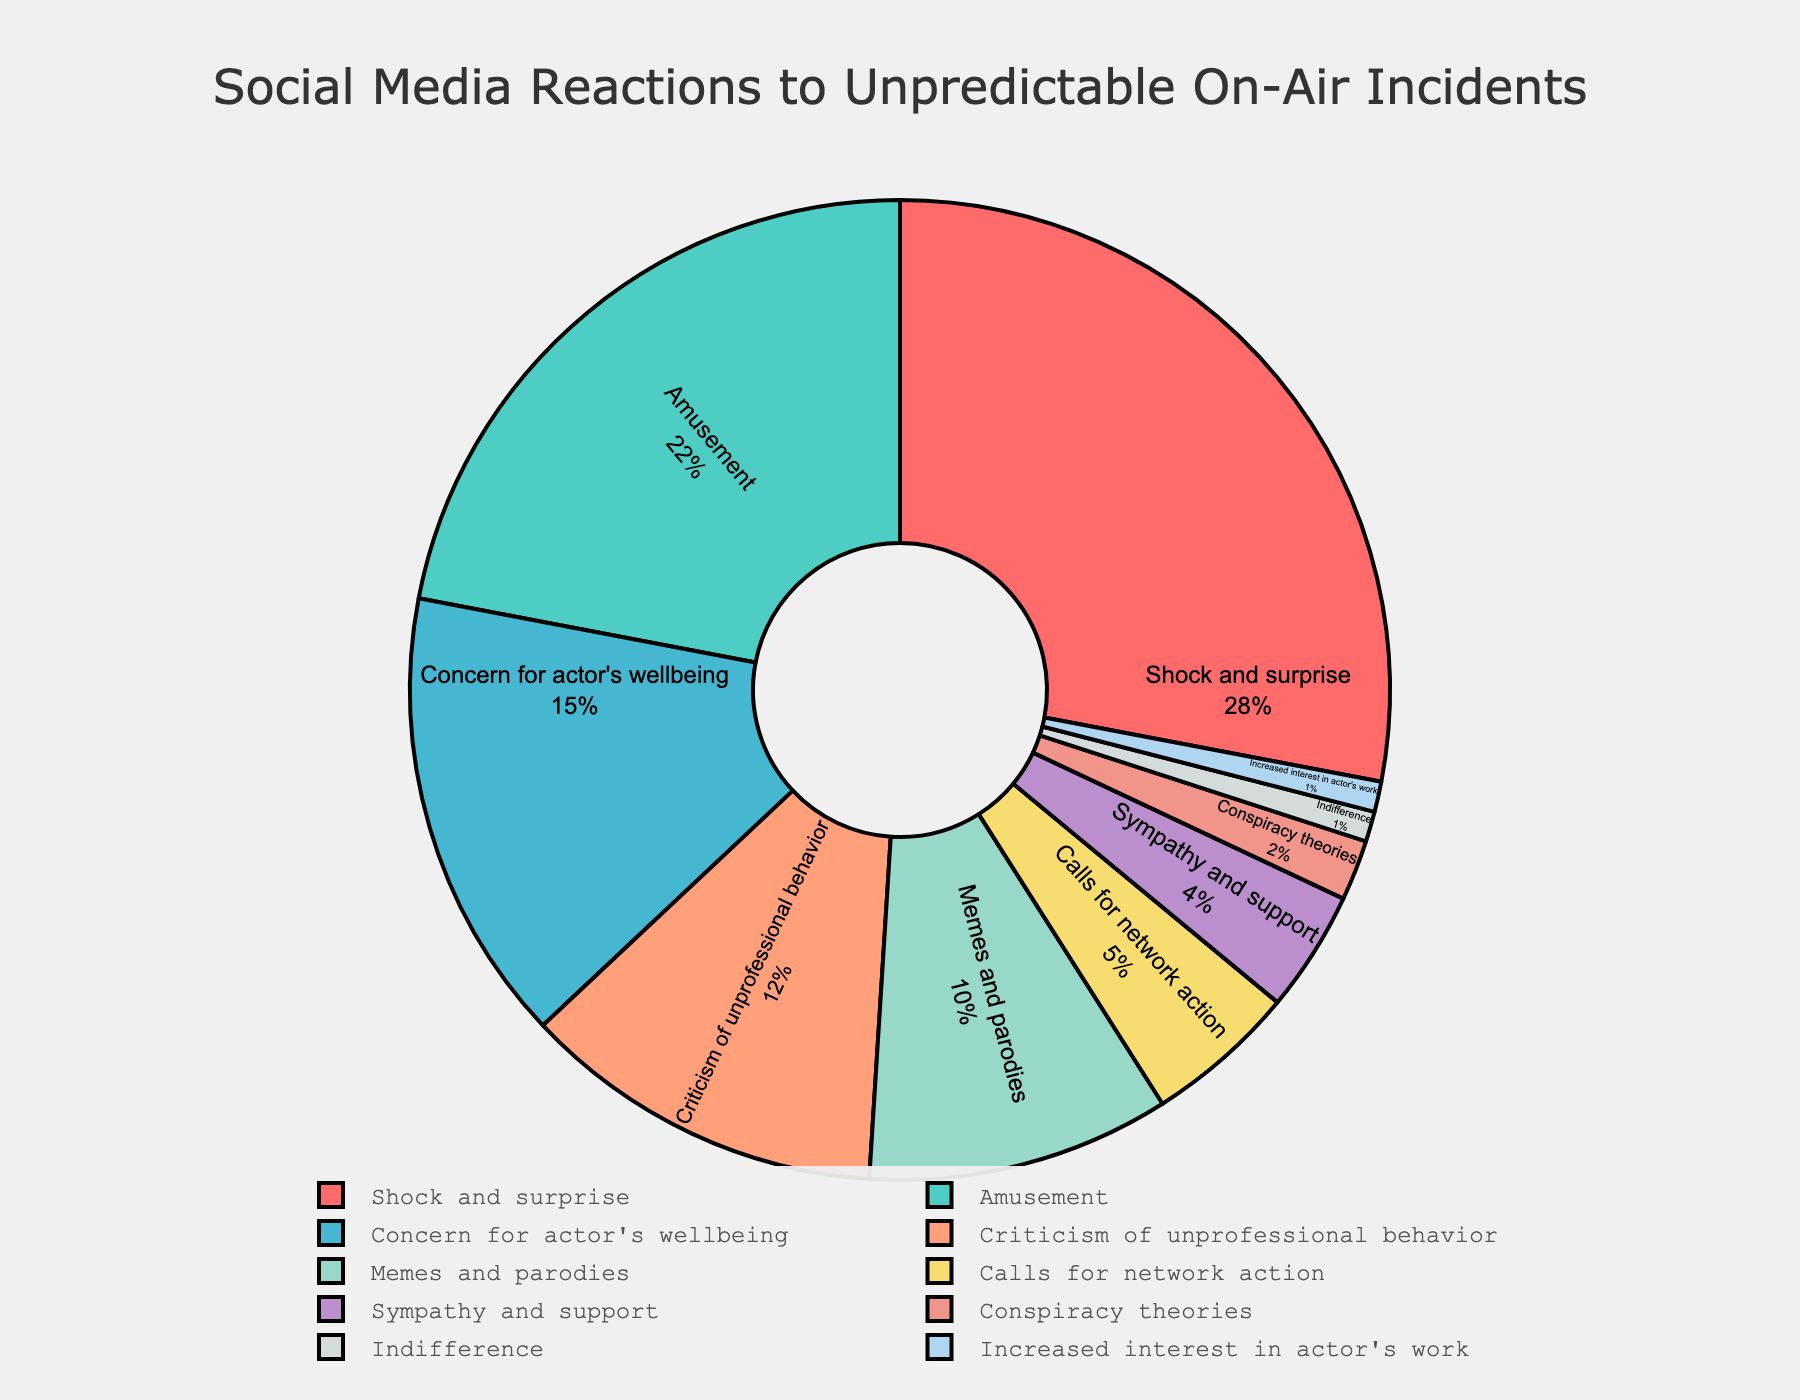What are the two highest percentage reactions to unpredictable on-air incidents? The pie chart shows the breakdown with each segment labeled with its respective percentage. The highest is "Shock and surprise" at 28%, followed by "Amusement" at 22%.
Answer: Shock and surprise, Amusement Which reaction has a higher percentage: Criticism of unprofessional behavior or Sympathy and support? Comparing the percentages in the pie chart, "Criticism of unprofessional behavior" is 12%, whereas "Sympathy and support" is 4%. Therefore, "Criticism of unprofessional behavior" is higher.
Answer: Criticism of unprofessional behavior What is the combined percentage of concern for actor's wellbeing and memes and parodies? The percentage for "Concern for actor's wellbeing" is 15% and for "Memes and parodies" is 10%. Adding these together gives 15% + 10% = 25%.
Answer: 25% Which reaction is indicated by the green segment in the pie chart? Observing the colors of the segments, the green segment corresponds to "Amusement".
Answer: Amusement By how much does the percentage of indifference differ from the percentage of increased interest in actor's work? The percentage for "Indifference" is 1% and for "Increased interest in actor's work" is also 1%. Therefore, the difference is 1% - 1% = 0%.
Answer: 0% Is the percentage of Calls for network action greater than the combined percentage of Conspiracy theories and Indifference? "Calls for network action" has a percentage of 5%. "Conspiracy theories" and "Indifference" have 2% and 1% respectively. Combined, they are 2% + 1% = 3%. Hence, 5% is greater than 3%.
Answer: Yes What is the total percentage of reactions categorized under Shock and surprise, Amusement, and Concern for actor's wellbeing? The percentages for "Shock and surprise", "Amusement", and "Concern for actor's wellbeing" are 28%, 22%, and 15% respectively. Adding these together gives 28% + 22% + 15% = 65%.
Answer: 65% 